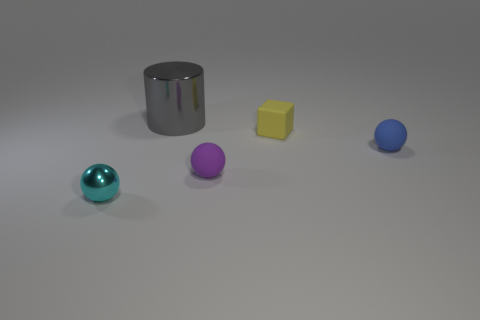Add 2 rubber spheres. How many objects exist? 7 Subtract all cylinders. How many objects are left? 4 Add 3 small blue rubber spheres. How many small blue rubber spheres are left? 4 Add 2 big gray metallic objects. How many big gray metallic objects exist? 3 Subtract 0 gray blocks. How many objects are left? 5 Subtract all small yellow matte cubes. Subtract all big blue metal spheres. How many objects are left? 4 